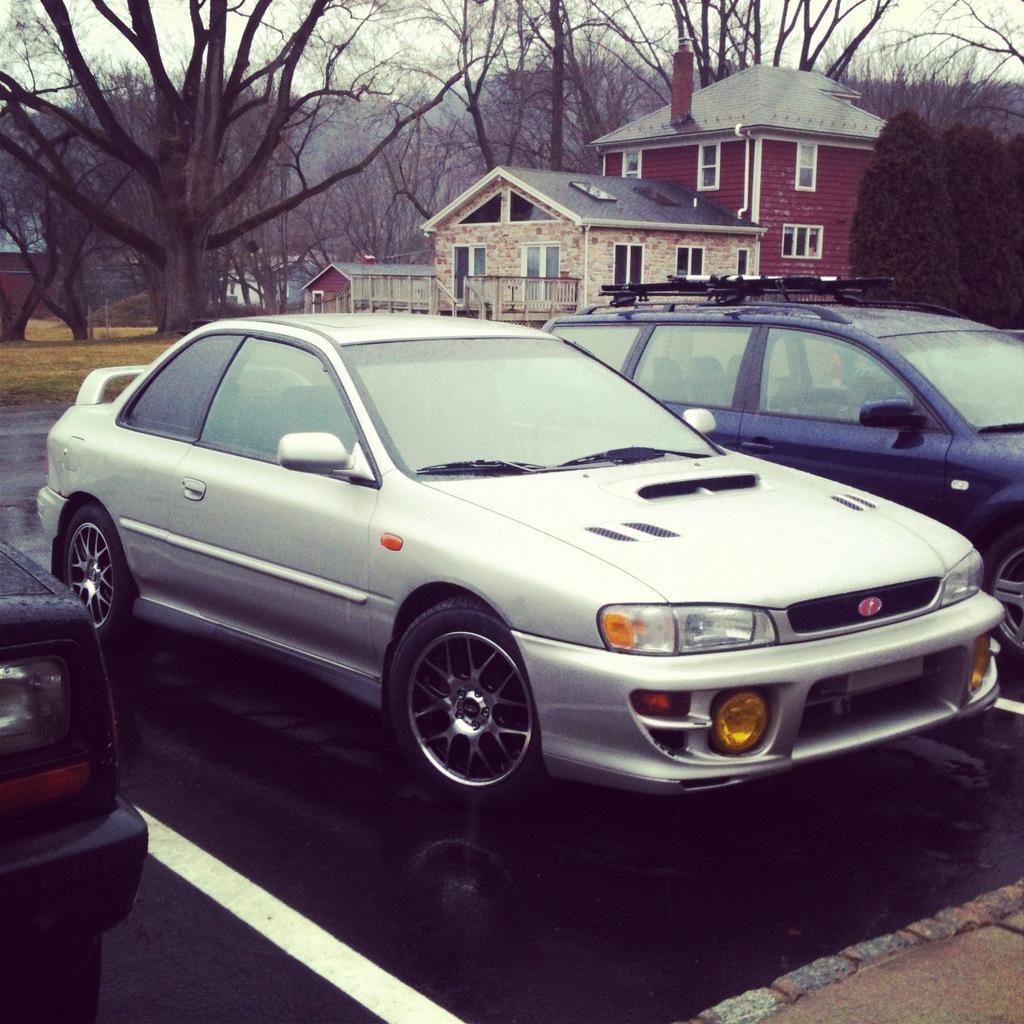How would you summarize this image in a sentence or two? In this picture I can see buildings and cars parked and I can see few trees and a cloudy sky. 